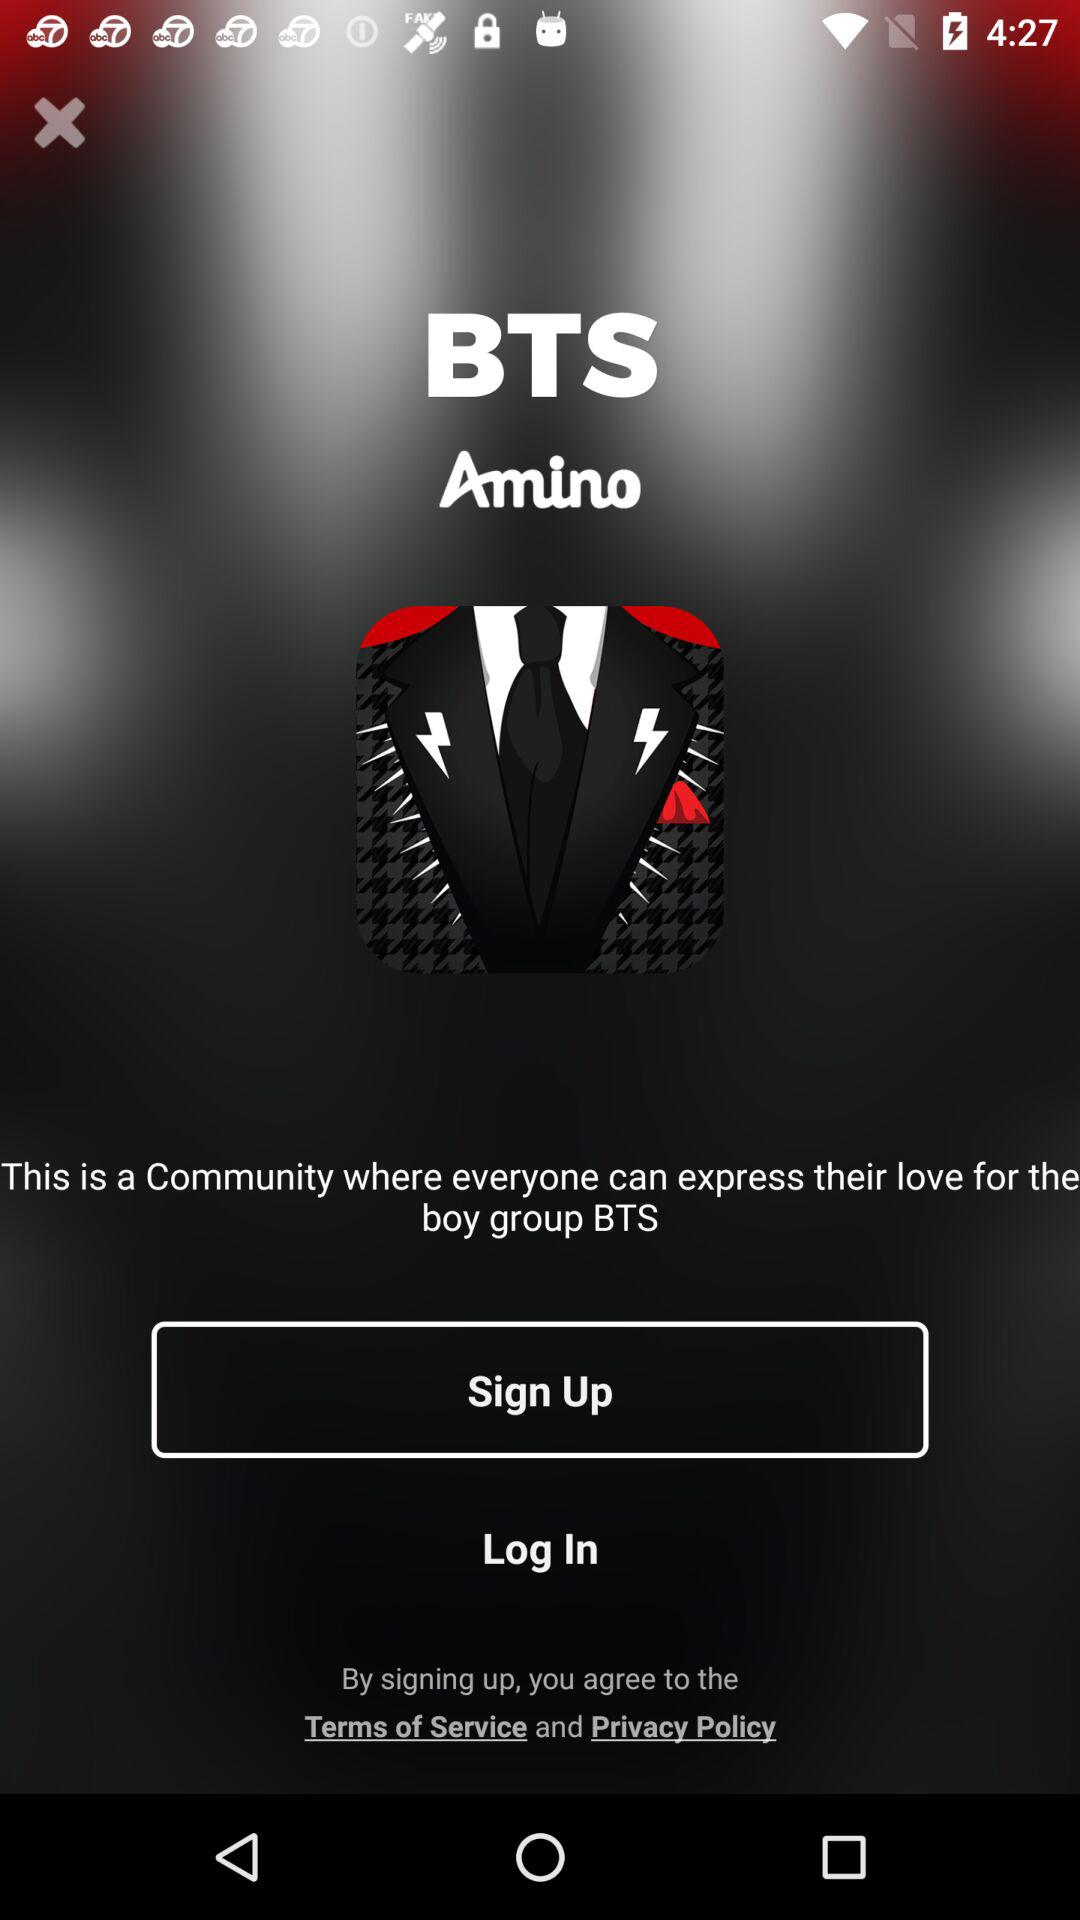What is the name of the application? The name of the application is "BTS Amino". 